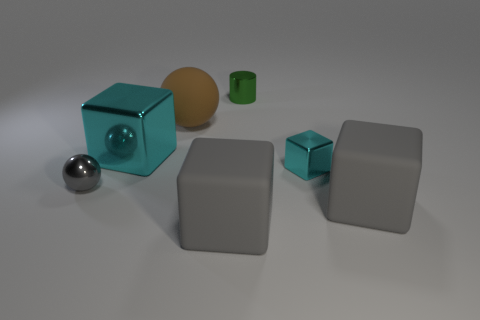Are there any patterns or consistencies in the sizes of objects? Yes, there are both consistencies and variations in the sizes of the objects. The two gray objects, although different in shape, are similar in size, while the other objects vary, with the brown orb being the largest and the small green cylinder being the smallest. 